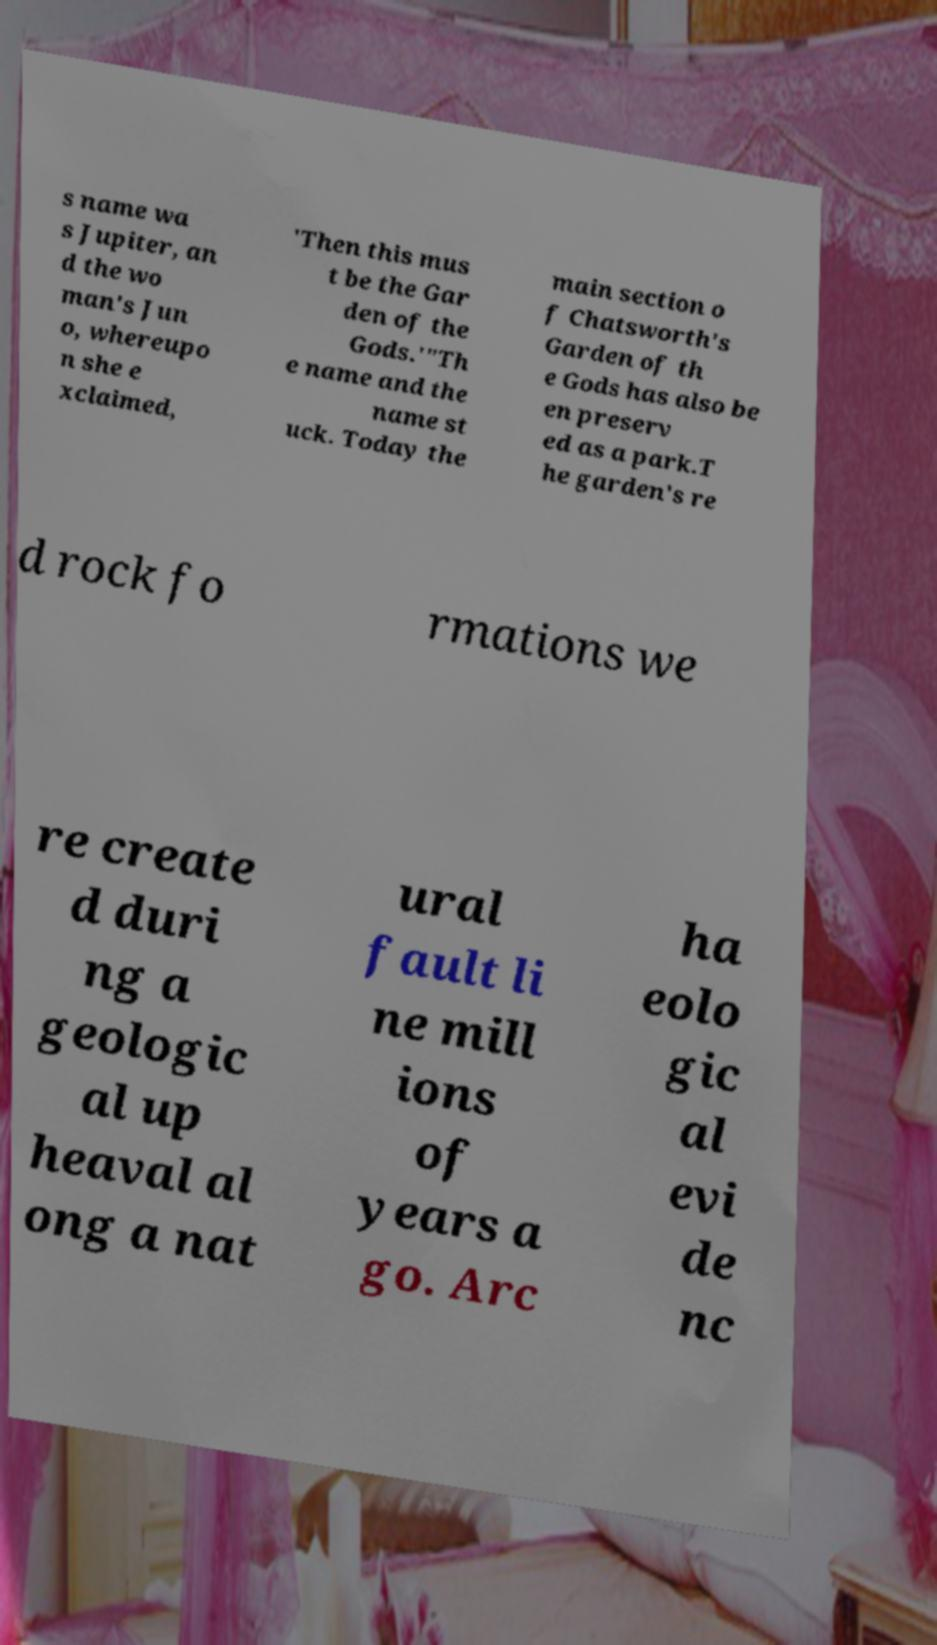What messages or text are displayed in this image? I need them in a readable, typed format. s name wa s Jupiter, an d the wo man's Jun o, whereupo n she e xclaimed, 'Then this mus t be the Gar den of the Gods.'"Th e name and the name st uck. Today the main section o f Chatsworth's Garden of th e Gods has also be en preserv ed as a park.T he garden's re d rock fo rmations we re create d duri ng a geologic al up heaval al ong a nat ural fault li ne mill ions of years a go. Arc ha eolo gic al evi de nc 